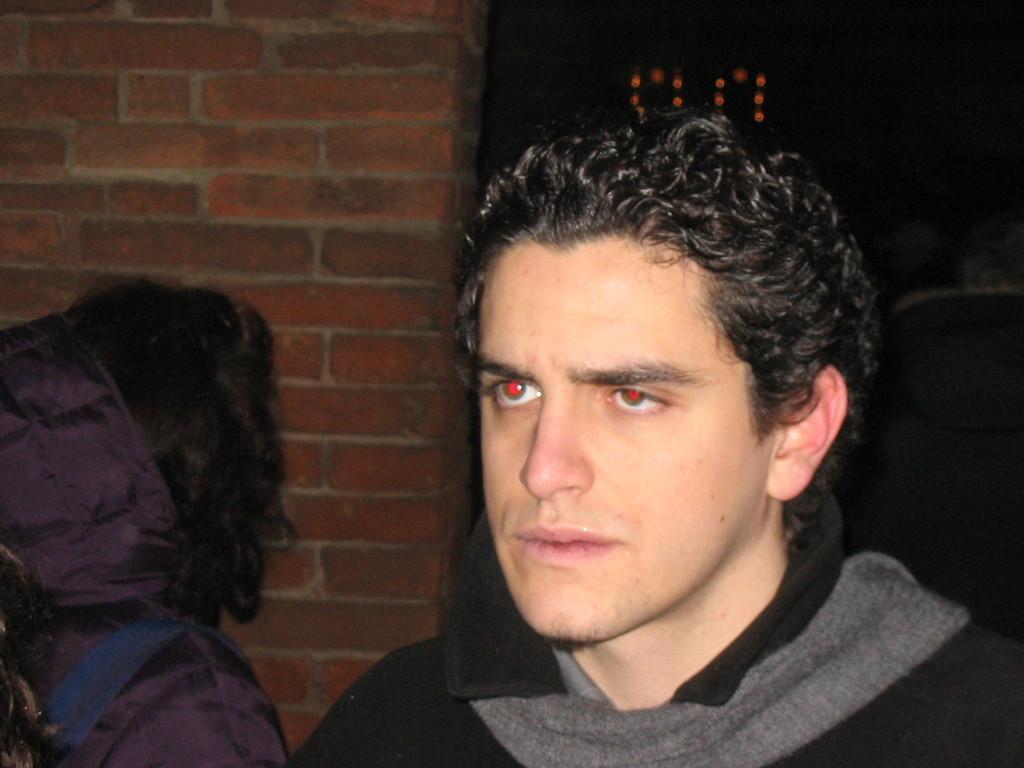Please provide a concise description of this image. In this picture we can see few people, in the background we can see a wall and few lights. 